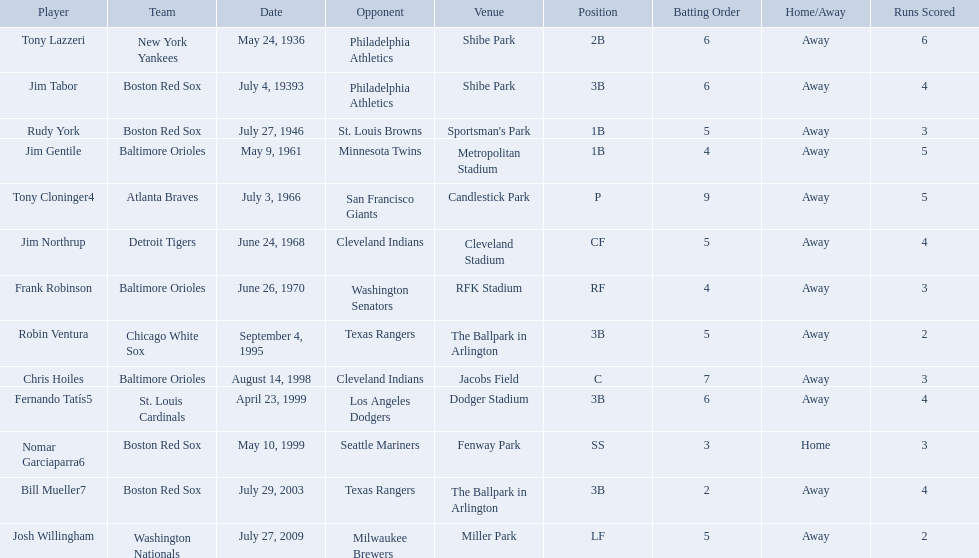What were the dates of each game? May 24, 1936, July 4, 19393, July 27, 1946, May 9, 1961, July 3, 1966, June 24, 1968, June 26, 1970, September 4, 1995, August 14, 1998, April 23, 1999, May 10, 1999, July 29, 2003, July 27, 2009. Who were all of the teams? New York Yankees, Boston Red Sox, Boston Red Sox, Baltimore Orioles, Atlanta Braves, Detroit Tigers, Baltimore Orioles, Chicago White Sox, Baltimore Orioles, St. Louis Cardinals, Boston Red Sox, Boston Red Sox, Washington Nationals. What about their opponents? Philadelphia Athletics, Philadelphia Athletics, St. Louis Browns, Minnesota Twins, San Francisco Giants, Cleveland Indians, Washington Senators, Texas Rangers, Cleveland Indians, Los Angeles Dodgers, Seattle Mariners, Texas Rangers, Milwaukee Brewers. And on which date did the detroit tigers play against the cleveland indians? June 24, 1968. Who are the opponents of the boston red sox during baseball home run records? Philadelphia Athletics, St. Louis Browns, Seattle Mariners, Texas Rangers. Of those which was the opponent on july 27, 1946? St. Louis Browns. Who are all the opponents? Philadelphia Athletics, Philadelphia Athletics, St. Louis Browns, Minnesota Twins, San Francisco Giants, Cleveland Indians, Washington Senators, Texas Rangers, Cleveland Indians, Los Angeles Dodgers, Seattle Mariners, Texas Rangers, Milwaukee Brewers. I'm looking to parse the entire table for insights. Could you assist me with that? {'header': ['Player', 'Team', 'Date', 'Opponent', 'Venue', 'Position', 'Batting Order', 'Home/Away', 'Runs Scored'], 'rows': [['Tony Lazzeri', 'New York Yankees', 'May 24, 1936', 'Philadelphia Athletics', 'Shibe Park', '2B', '6', 'Away', '6'], ['Jim Tabor', 'Boston Red Sox', 'July 4, 19393', 'Philadelphia Athletics', 'Shibe Park', '3B', '6', 'Away', '4'], ['Rudy York', 'Boston Red Sox', 'July 27, 1946', 'St. Louis Browns', "Sportsman's Park", '1B', '5', 'Away', '3'], ['Jim Gentile', 'Baltimore Orioles', 'May 9, 1961', 'Minnesota Twins', 'Metropolitan Stadium', '1B', '4', 'Away', '5'], ['Tony Cloninger4', 'Atlanta Braves', 'July 3, 1966', 'San Francisco Giants', 'Candlestick Park', 'P', '9', 'Away', '5'], ['Jim Northrup', 'Detroit Tigers', 'June 24, 1968', 'Cleveland Indians', 'Cleveland Stadium', 'CF', '5', 'Away', '4'], ['Frank Robinson', 'Baltimore Orioles', 'June 26, 1970', 'Washington Senators', 'RFK Stadium', 'RF', '4', 'Away', '3'], ['Robin Ventura', 'Chicago White Sox', 'September 4, 1995', 'Texas Rangers', 'The Ballpark in Arlington', '3B', '5', 'Away', '2'], ['Chris Hoiles', 'Baltimore Orioles', 'August 14, 1998', 'Cleveland Indians', 'Jacobs Field', 'C', '7', 'Away', '3'], ['Fernando Tatís5', 'St. Louis Cardinals', 'April 23, 1999', 'Los Angeles Dodgers', 'Dodger Stadium', '3B', '6', 'Away', '4'], ['Nomar Garciaparra6', 'Boston Red Sox', 'May 10, 1999', 'Seattle Mariners', 'Fenway Park', 'SS', '3', 'Home', '3'], ['Bill Mueller7', 'Boston Red Sox', 'July 29, 2003', 'Texas Rangers', 'The Ballpark in Arlington', '3B', '2', 'Away', '4'], ['Josh Willingham', 'Washington Nationals', 'July 27, 2009', 'Milwaukee Brewers', 'Miller Park', 'LF', '5', 'Away', '2']]} What teams played on july 27, 1946? Boston Red Sox, July 27, 1946, St. Louis Browns. Who was the opponent in this game? St. Louis Browns. Who were all the teams? New York Yankees, Boston Red Sox, Boston Red Sox, Baltimore Orioles, Atlanta Braves, Detroit Tigers, Baltimore Orioles, Chicago White Sox, Baltimore Orioles, St. Louis Cardinals, Boston Red Sox, Boston Red Sox, Washington Nationals. What about opponents? Philadelphia Athletics, Philadelphia Athletics, St. Louis Browns, Minnesota Twins, San Francisco Giants, Cleveland Indians, Washington Senators, Texas Rangers, Cleveland Indians, Los Angeles Dodgers, Seattle Mariners, Texas Rangers, Milwaukee Brewers. And when did they play? May 24, 1936, July 4, 19393, July 27, 1946, May 9, 1961, July 3, 1966, June 24, 1968, June 26, 1970, September 4, 1995, August 14, 1998, April 23, 1999, May 10, 1999, July 29, 2003, July 27, 2009. Which team played the red sox on july 27, 1946	? St. Louis Browns. 